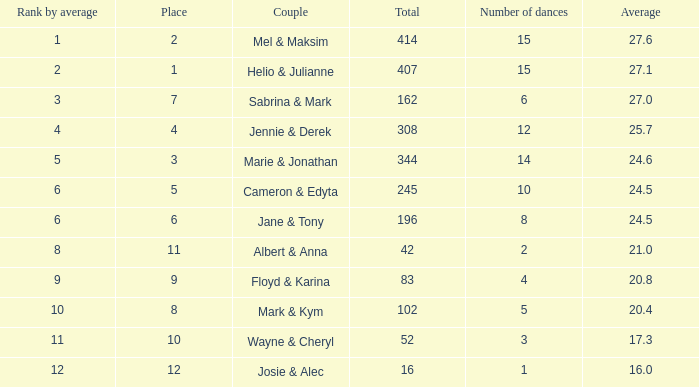What is the average place for a couple with the rank by average of 9 and total smaller than 83? None. 